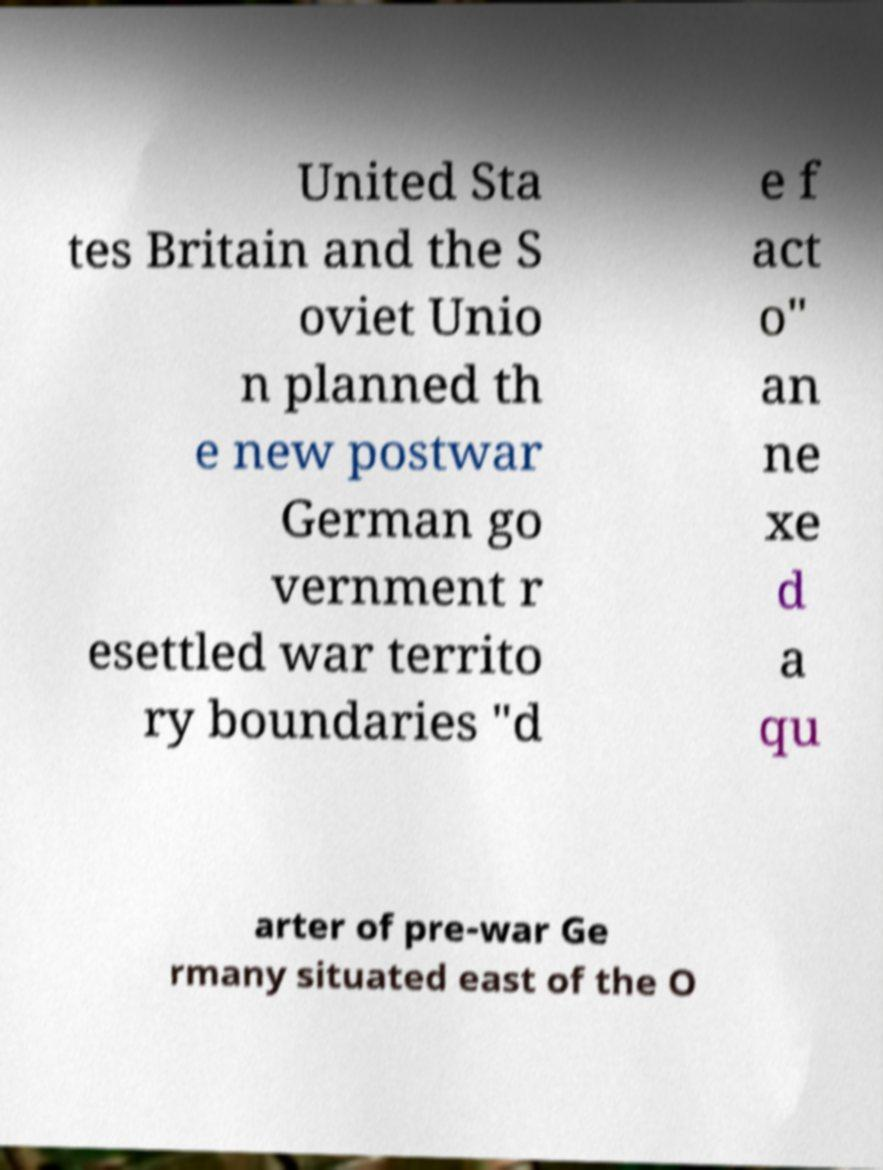Please read and relay the text visible in this image. What does it say? United Sta tes Britain and the S oviet Unio n planned th e new postwar German go vernment r esettled war territo ry boundaries "d e f act o" an ne xe d a qu arter of pre-war Ge rmany situated east of the O 